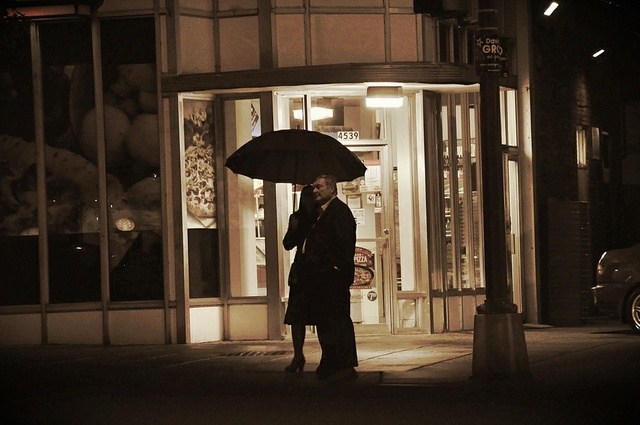Describe the objects in this image and their specific colors. I can see people in black, maroon, and gray tones, umbrella in black, ivory, and tan tones, car in black, maroon, and gray tones, and people in black, maroon, and gray tones in this image. 